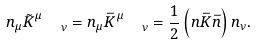Convert formula to latex. <formula><loc_0><loc_0><loc_500><loc_500>n _ { \mu } \tilde { K } ^ { \mu } _ { \quad \nu } = n _ { \mu } \bar { K } ^ { \mu } _ { \quad \nu } = \frac { 1 } { 2 } \left ( n \bar { K } \bar { n } \right ) n _ { \nu } .</formula> 